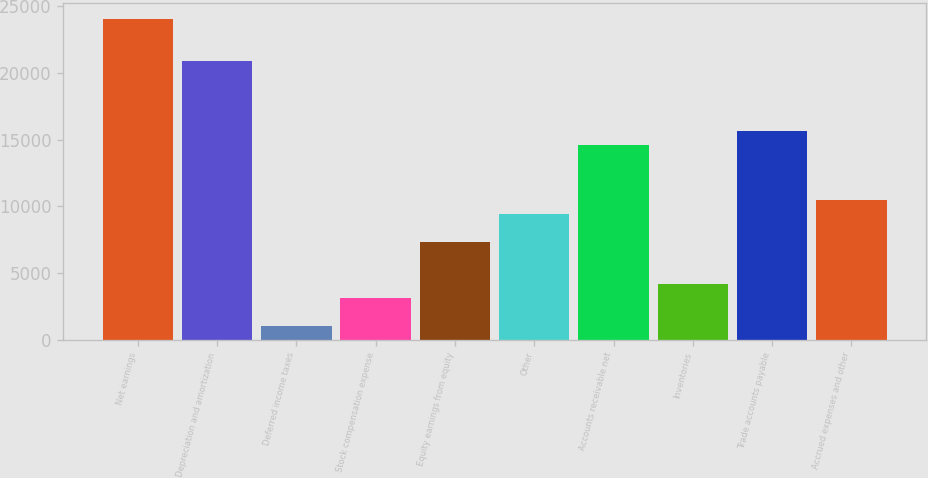Convert chart. <chart><loc_0><loc_0><loc_500><loc_500><bar_chart><fcel>Net earnings<fcel>Depreciation and amortization<fcel>Deferred income taxes<fcel>Stock compensation expense<fcel>Equity earnings from equity<fcel>Other<fcel>Accounts receivable net<fcel>Inventories<fcel>Trade accounts payable<fcel>Accrued expenses and other<nl><fcel>24048.6<fcel>20913<fcel>1054.2<fcel>3144.6<fcel>7325.4<fcel>9415.8<fcel>14641.8<fcel>4189.8<fcel>15687<fcel>10461<nl></chart> 